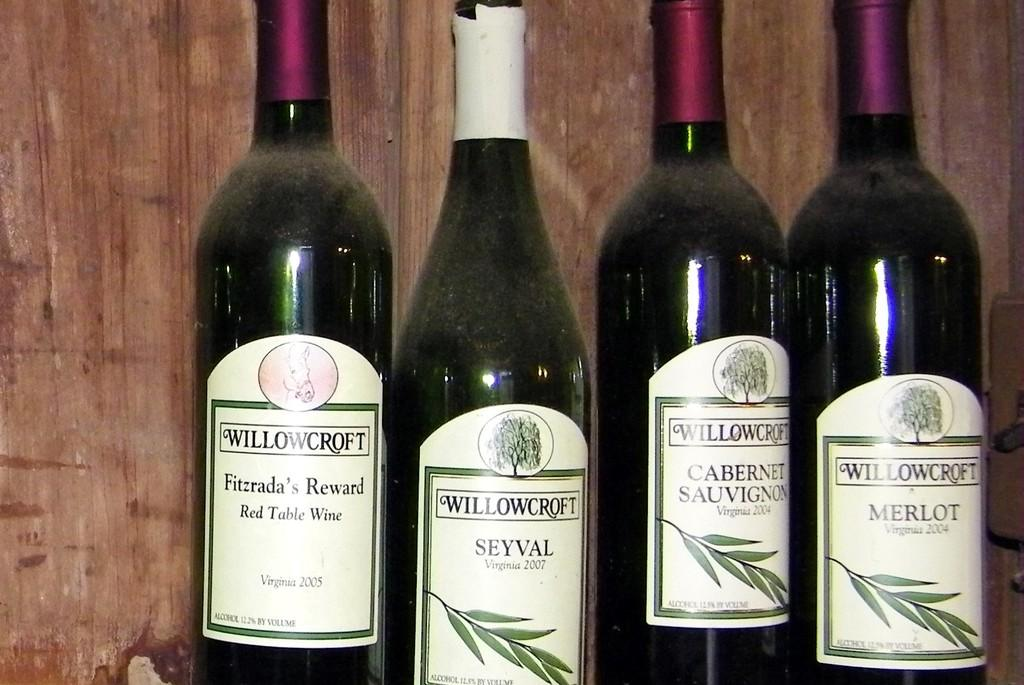<image>
Summarize the visual content of the image. Various bottles of Willowcroft wines are lined up in a row. 